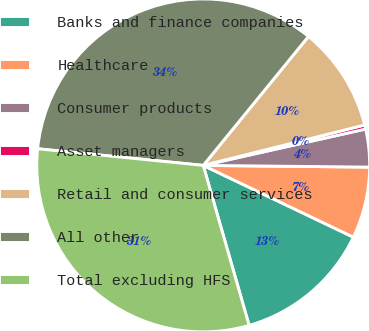<chart> <loc_0><loc_0><loc_500><loc_500><pie_chart><fcel>Banks and finance companies<fcel>Healthcare<fcel>Consumer products<fcel>Asset managers<fcel>Retail and consumer services<fcel>All other<fcel>Total excluding HFS<nl><fcel>13.46%<fcel>6.93%<fcel>3.67%<fcel>0.4%<fcel>10.2%<fcel>34.3%<fcel>31.04%<nl></chart> 